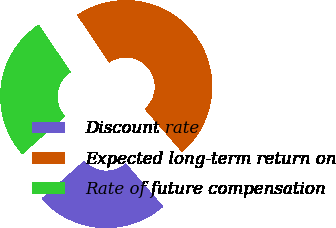<chart> <loc_0><loc_0><loc_500><loc_500><pie_chart><fcel>Discount rate<fcel>Expected long-term return on<fcel>Rate of future compensation<nl><fcel>24.8%<fcel>48.05%<fcel>27.15%<nl></chart> 